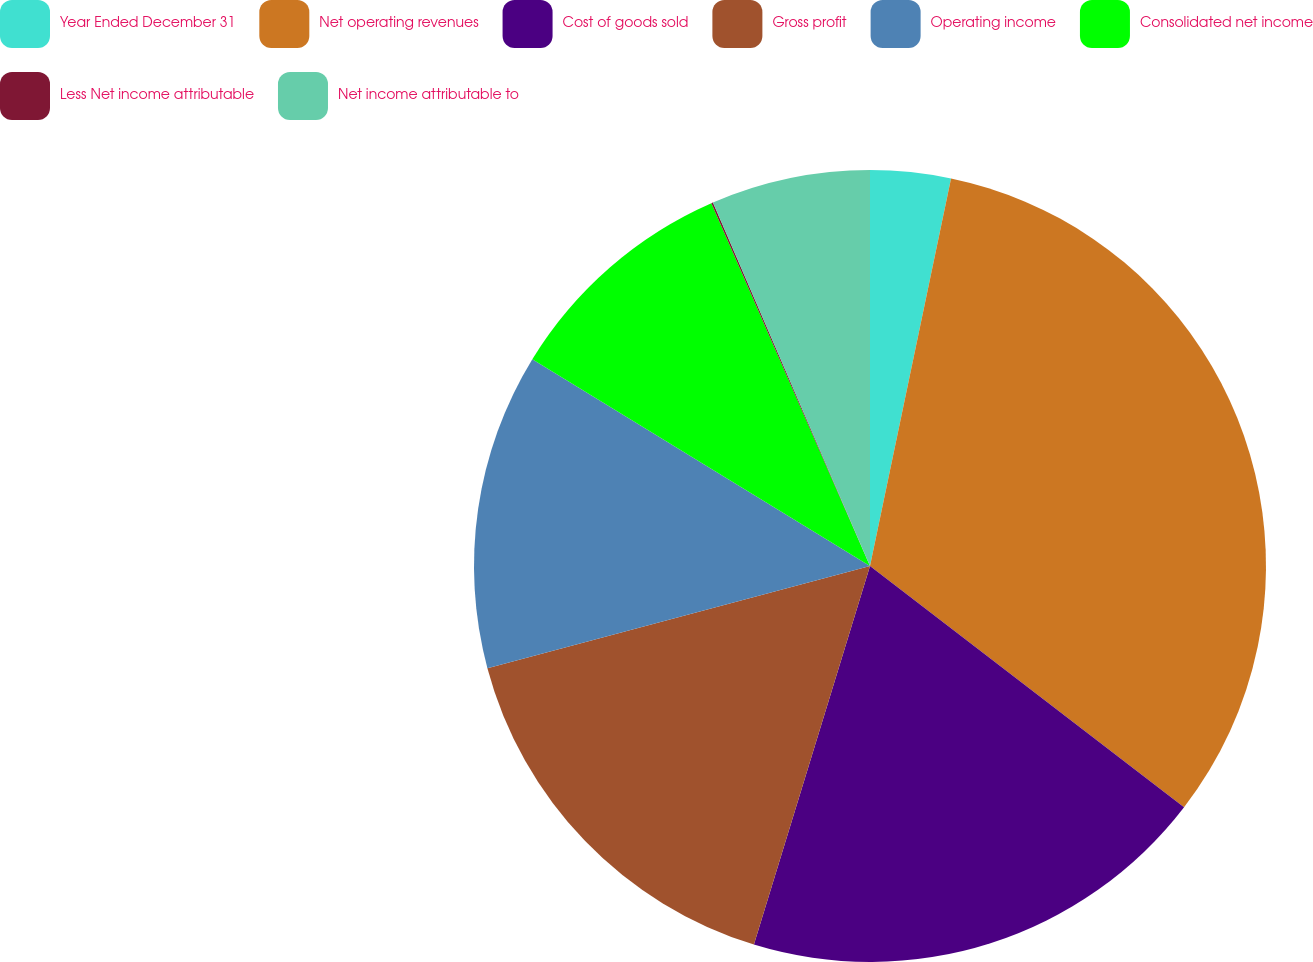Convert chart. <chart><loc_0><loc_0><loc_500><loc_500><pie_chart><fcel>Year Ended December 31<fcel>Net operating revenues<fcel>Cost of goods sold<fcel>Gross profit<fcel>Operating income<fcel>Consolidated net income<fcel>Less Net income attributable<fcel>Net income attributable to<nl><fcel>3.28%<fcel>32.14%<fcel>19.31%<fcel>16.11%<fcel>12.9%<fcel>9.69%<fcel>0.07%<fcel>6.49%<nl></chart> 